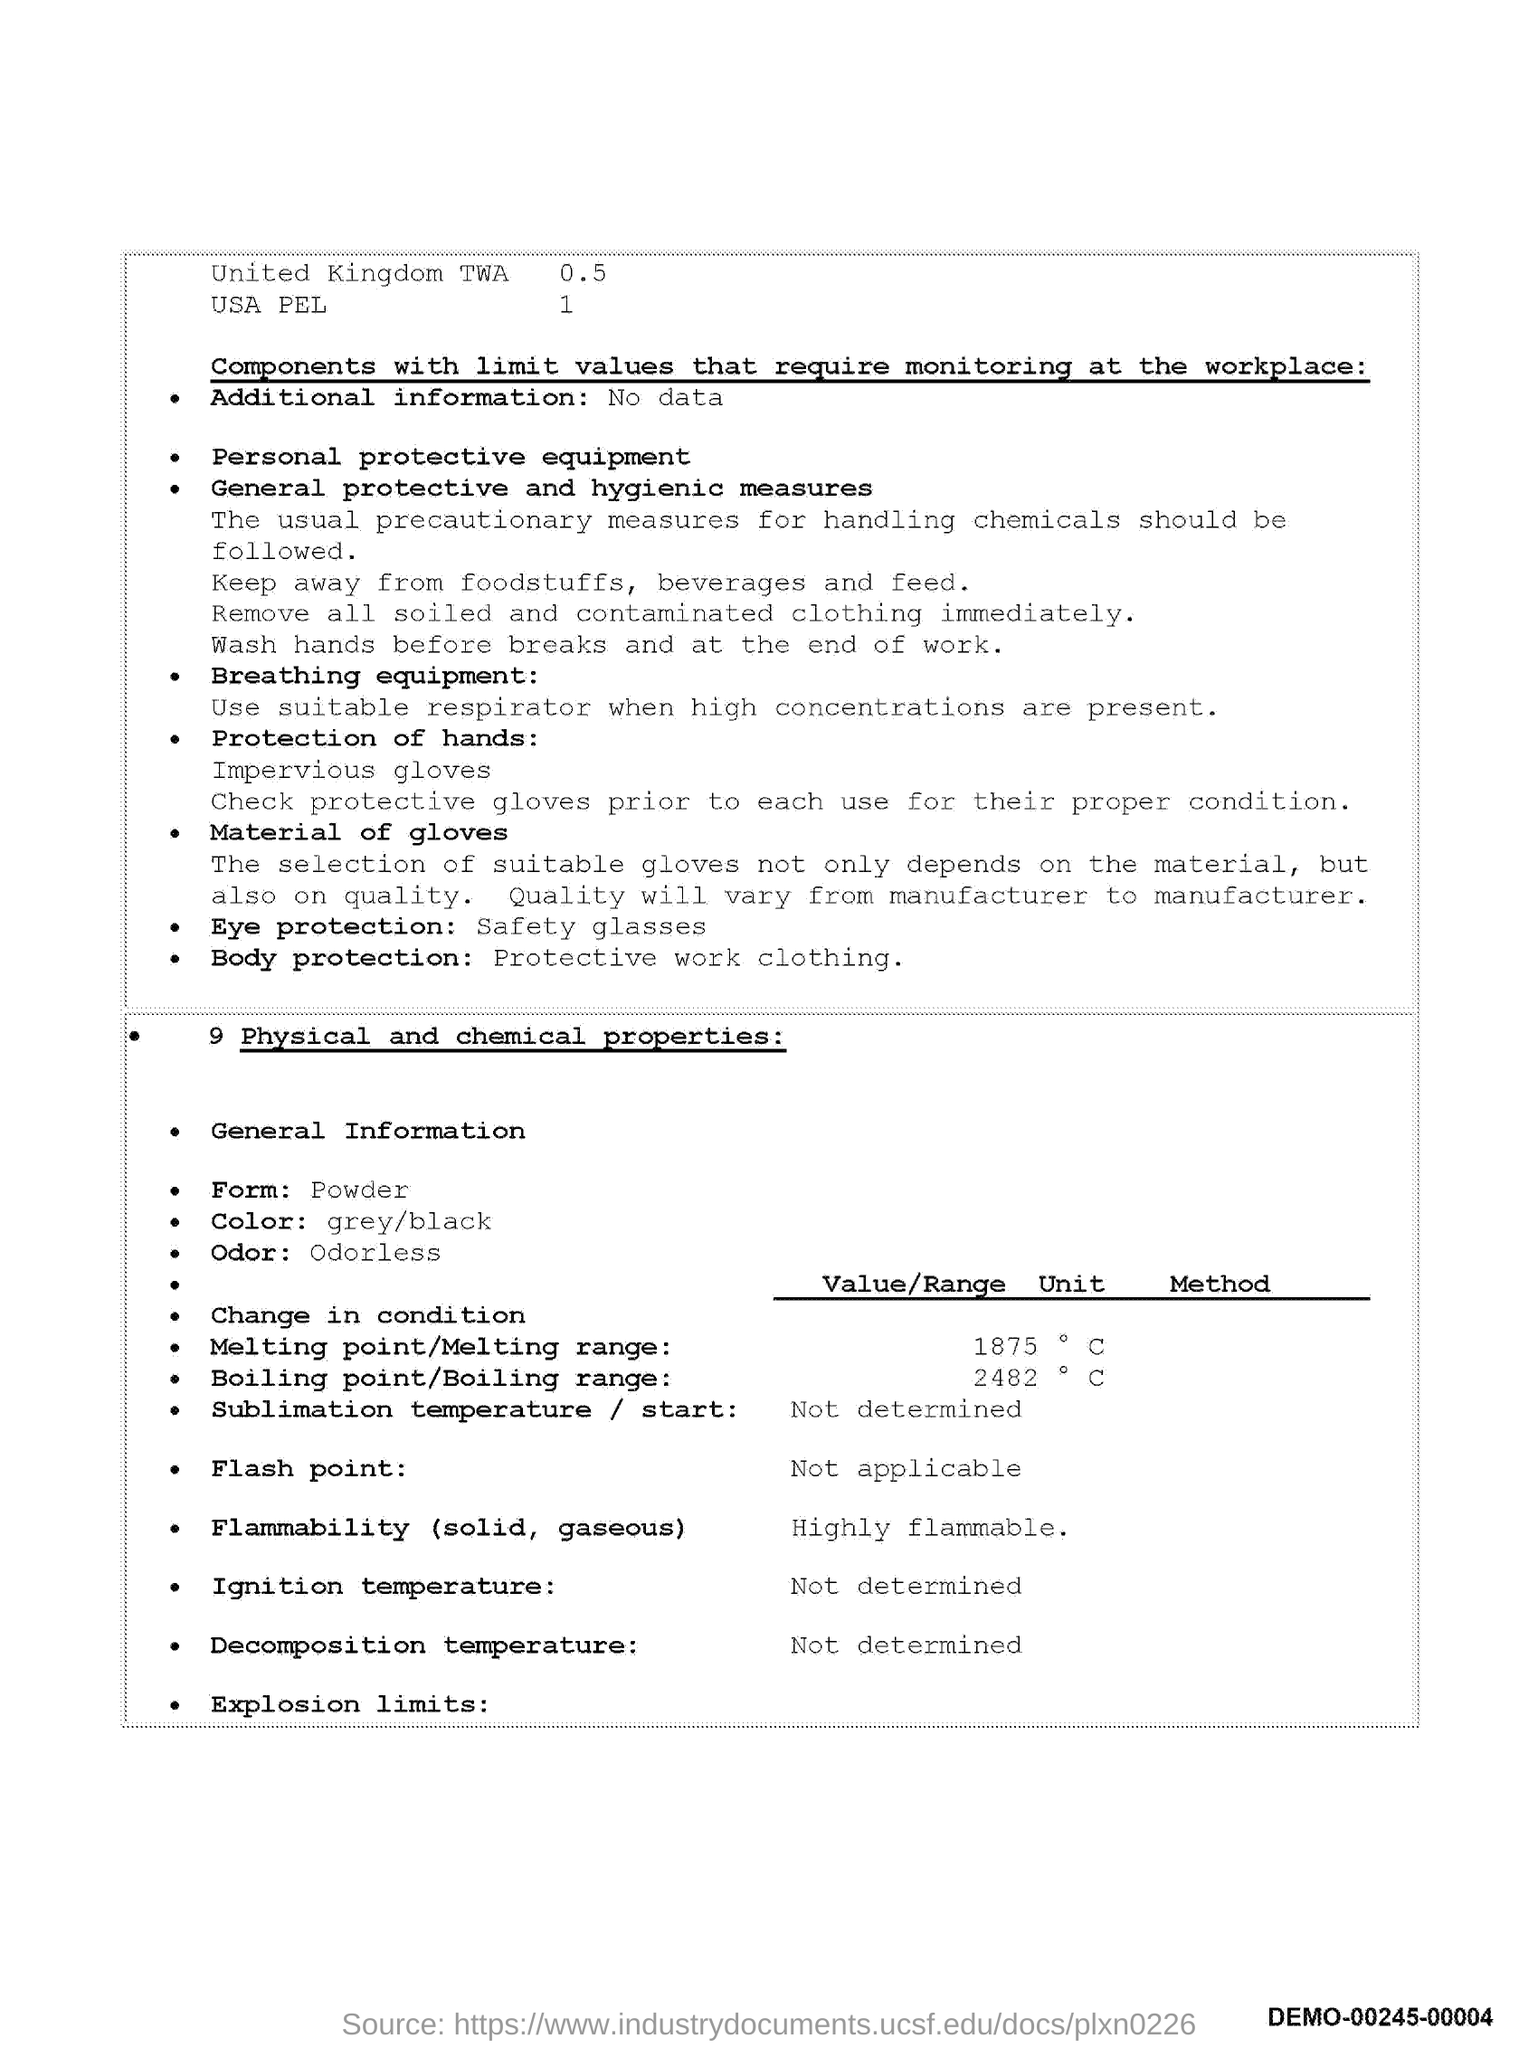Draw attention to some important aspects in this diagram. The material is available in the form of powder. The color mentioned in the document is grey/black. The melting point is 1875. What is the boiling point value of 2482? 